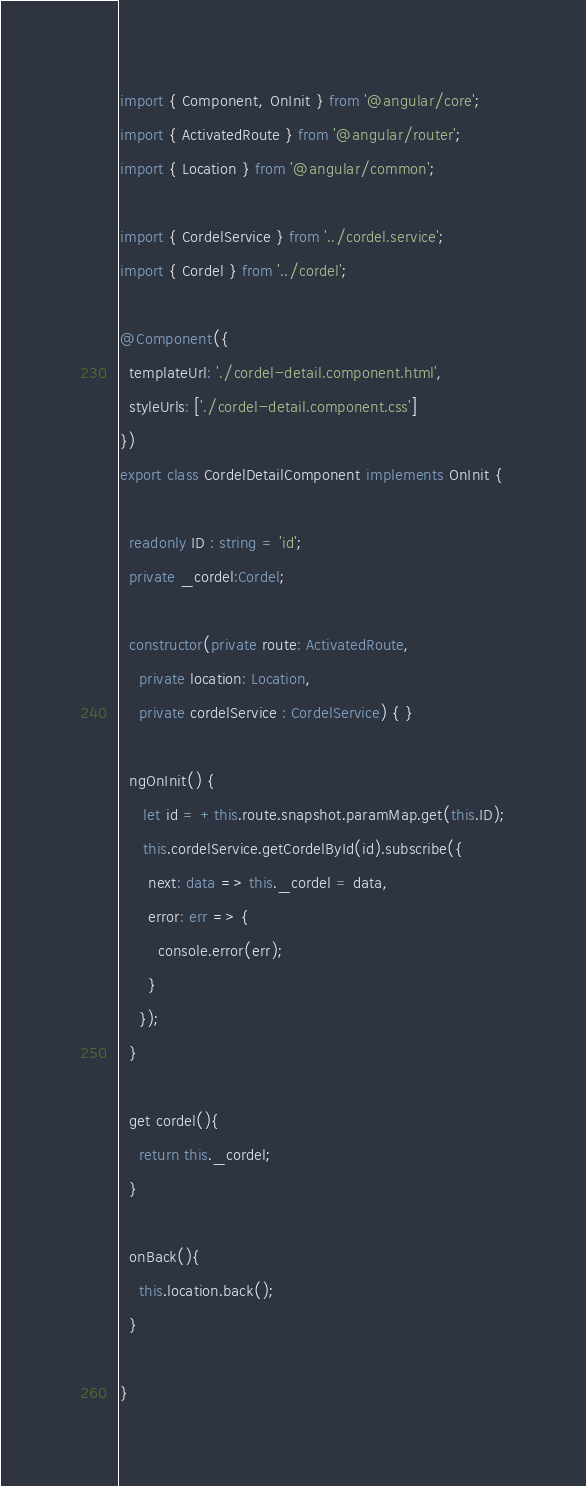<code> <loc_0><loc_0><loc_500><loc_500><_TypeScript_>import { Component, OnInit } from '@angular/core';
import { ActivatedRoute } from '@angular/router';
import { Location } from '@angular/common';

import { CordelService } from '../cordel.service';
import { Cordel } from '../cordel';

@Component({
  templateUrl: './cordel-detail.component.html',
  styleUrls: ['./cordel-detail.component.css']
})
export class CordelDetailComponent implements OnInit {

  readonly ID : string = 'id';
  private _cordel:Cordel;

  constructor(private route: ActivatedRoute, 
    private location: Location,
    private cordelService : CordelService) { }

  ngOnInit() {
     let id = +this.route.snapshot.paramMap.get(this.ID);
     this.cordelService.getCordelById(id).subscribe({
      next: data => this._cordel = data,
      error: err => {
        console.error(err);
      }
    });
  }

  get cordel(){
    return this._cordel;
  }

  onBack(){
    this.location.back();
  }

}
</code> 